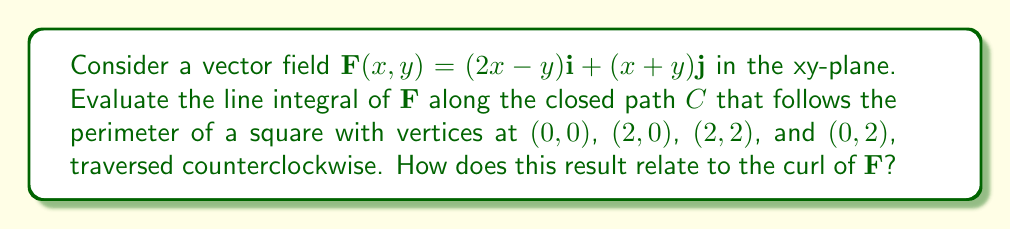Provide a solution to this math problem. To evaluate this line integral, we'll use Green's theorem, which relates a line integral around a closed curve to a double integral over the region enclosed by the curve. This approach is particularly relevant for engineering applications, as it often simplifies complex calculations.

Green's theorem states:

$$\oint_C (P dx + Q dy) = \iint_R \left(\frac{\partial Q}{\partial x} - \frac{\partial P}{\partial y}\right) dA$$

Where $\mathbf{F}(x,y) = P(x,y)\mathbf{i} + Q(x,y)\mathbf{j}$.

In our case:
$P(x,y) = 2x-y$ and $Q(x,y) = x+y$

Step 1: Calculate $\frac{\partial Q}{\partial x} - \frac{\partial P}{\partial y}$
$$\frac{\partial Q}{\partial x} = 1$$
$$\frac{\partial P}{\partial y} = -1$$
$$\frac{\partial Q}{\partial x} - \frac{\partial P}{\partial y} = 1 - (-1) = 2$$

Step 2: Set up the double integral
The region $R$ is a square with sides of length 2, so our integral becomes:

$$\iint_R 2 dA = 2 \int_0^2 \int_0^2 dx dy$$

Step 3: Evaluate the double integral
$$2 \int_0^2 \int_0^2 dx dy = 2 \cdot 2 \cdot 2 = 8$$

Therefore, the line integral of $\mathbf{F}$ along the closed path $C$ is 8.

Relation to curl:
The expression $\frac{\partial Q}{\partial x} - \frac{\partial P}{\partial y}$ is actually the z-component of the curl of $\mathbf{F}$ in 2D, denoted as $\text{curl}\mathbf{F}$ or $\nabla \times \mathbf{F}$. In this case, $\text{curl}\mathbf{F} = 2$, which is constant over the entire region.

The line integral result (8) is equal to the flux of the curl through the enclosed region, which is the curl (2) multiplied by the area of the square (4). This relationship is a consequence of Stokes' theorem, a generalization of Green's theorem to three dimensions.
Answer: The line integral of $\mathbf{F}(x,y) = (2x-y)\mathbf{i} + (x+y)\mathbf{j}$ along the given closed path is 8. This result is equal to the flux of the curl of $\mathbf{F}$ through the enclosed region, where $\text{curl}\mathbf{F} = 2$. 